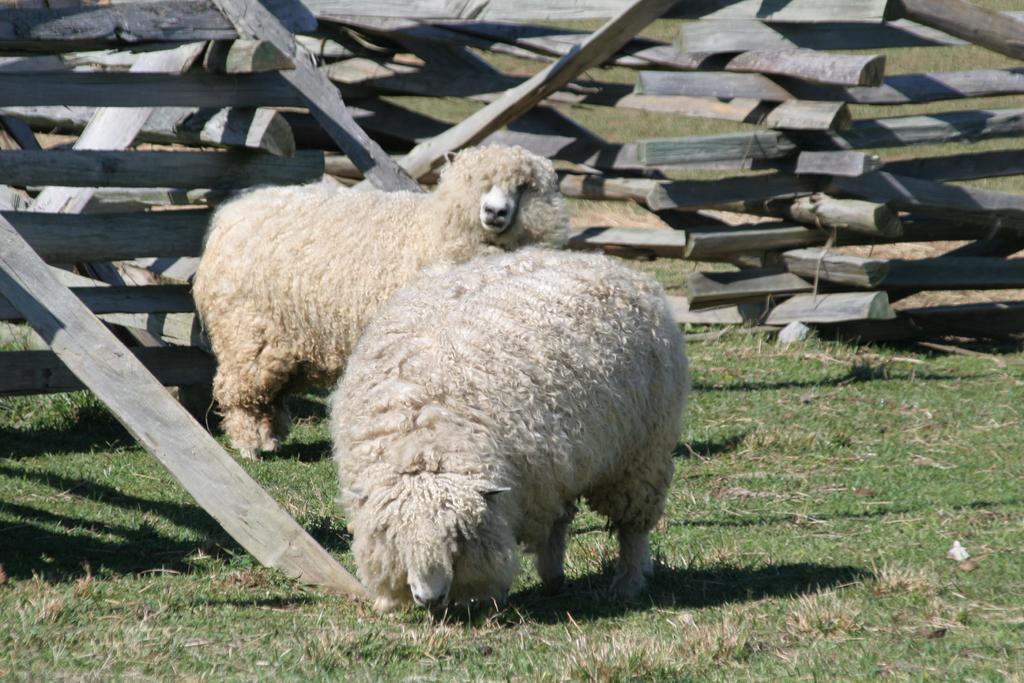Please provide a concise description of this image. In this image there are two sheep present on the grass. In the background we can see some wooden sticks arranged in a manner. 